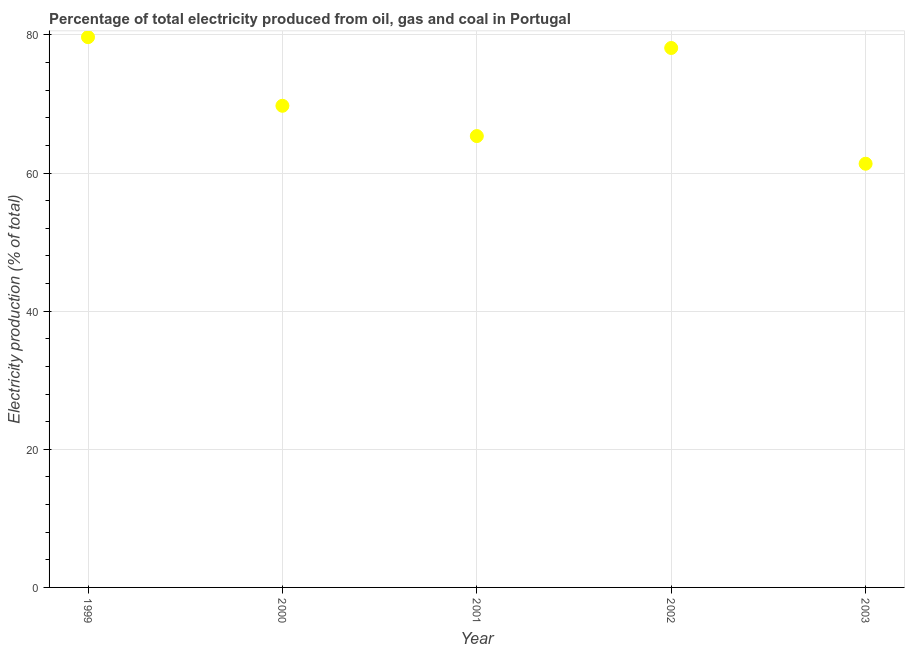What is the electricity production in 1999?
Keep it short and to the point. 79.67. Across all years, what is the maximum electricity production?
Offer a very short reply. 79.67. Across all years, what is the minimum electricity production?
Your answer should be very brief. 61.35. In which year was the electricity production maximum?
Give a very brief answer. 1999. What is the sum of the electricity production?
Ensure brevity in your answer.  354.22. What is the difference between the electricity production in 2001 and 2002?
Give a very brief answer. -12.75. What is the average electricity production per year?
Your response must be concise. 70.84. What is the median electricity production?
Your answer should be very brief. 69.74. Do a majority of the years between 2001 and 2000 (inclusive) have electricity production greater than 36 %?
Provide a succinct answer. No. What is the ratio of the electricity production in 1999 to that in 2003?
Offer a terse response. 1.3. Is the difference between the electricity production in 1999 and 2003 greater than the difference between any two years?
Give a very brief answer. Yes. What is the difference between the highest and the second highest electricity production?
Make the answer very short. 1.57. What is the difference between the highest and the lowest electricity production?
Your answer should be compact. 18.33. What is the difference between two consecutive major ticks on the Y-axis?
Ensure brevity in your answer.  20. Does the graph contain any zero values?
Keep it short and to the point. No. What is the title of the graph?
Your answer should be very brief. Percentage of total electricity produced from oil, gas and coal in Portugal. What is the label or title of the Y-axis?
Provide a succinct answer. Electricity production (% of total). What is the Electricity production (% of total) in 1999?
Provide a short and direct response. 79.67. What is the Electricity production (% of total) in 2000?
Your response must be concise. 69.74. What is the Electricity production (% of total) in 2001?
Offer a terse response. 65.35. What is the Electricity production (% of total) in 2002?
Make the answer very short. 78.11. What is the Electricity production (% of total) in 2003?
Provide a short and direct response. 61.35. What is the difference between the Electricity production (% of total) in 1999 and 2000?
Offer a terse response. 9.94. What is the difference between the Electricity production (% of total) in 1999 and 2001?
Provide a succinct answer. 14.32. What is the difference between the Electricity production (% of total) in 1999 and 2002?
Offer a terse response. 1.57. What is the difference between the Electricity production (% of total) in 1999 and 2003?
Your response must be concise. 18.33. What is the difference between the Electricity production (% of total) in 2000 and 2001?
Keep it short and to the point. 4.39. What is the difference between the Electricity production (% of total) in 2000 and 2002?
Provide a short and direct response. -8.37. What is the difference between the Electricity production (% of total) in 2000 and 2003?
Offer a very short reply. 8.39. What is the difference between the Electricity production (% of total) in 2001 and 2002?
Your answer should be very brief. -12.75. What is the difference between the Electricity production (% of total) in 2001 and 2003?
Ensure brevity in your answer.  4. What is the difference between the Electricity production (% of total) in 2002 and 2003?
Provide a short and direct response. 16.76. What is the ratio of the Electricity production (% of total) in 1999 to that in 2000?
Make the answer very short. 1.14. What is the ratio of the Electricity production (% of total) in 1999 to that in 2001?
Provide a short and direct response. 1.22. What is the ratio of the Electricity production (% of total) in 1999 to that in 2002?
Provide a short and direct response. 1.02. What is the ratio of the Electricity production (% of total) in 1999 to that in 2003?
Your answer should be very brief. 1.3. What is the ratio of the Electricity production (% of total) in 2000 to that in 2001?
Ensure brevity in your answer.  1.07. What is the ratio of the Electricity production (% of total) in 2000 to that in 2002?
Keep it short and to the point. 0.89. What is the ratio of the Electricity production (% of total) in 2000 to that in 2003?
Provide a short and direct response. 1.14. What is the ratio of the Electricity production (% of total) in 2001 to that in 2002?
Your response must be concise. 0.84. What is the ratio of the Electricity production (% of total) in 2001 to that in 2003?
Your response must be concise. 1.06. What is the ratio of the Electricity production (% of total) in 2002 to that in 2003?
Give a very brief answer. 1.27. 